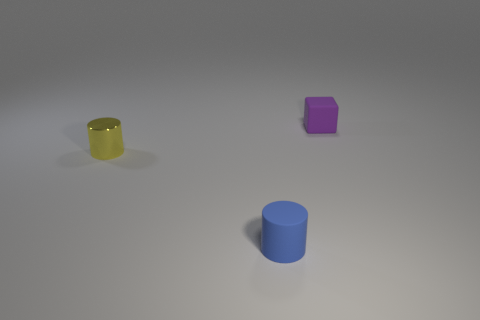What color is the other tiny thing that is the same shape as the small yellow object?
Provide a short and direct response. Blue. Are the blue cylinder and the yellow object made of the same material?
Your answer should be very brief. No. The metallic object that is the same size as the matte block is what color?
Your answer should be very brief. Yellow. Is there a tiny matte thing that has the same shape as the tiny yellow shiny thing?
Your response must be concise. Yes. There is a thing to the left of the matte object to the left of the rubber object behind the small yellow object; what is it made of?
Ensure brevity in your answer.  Metal. The metal thing is what color?
Your answer should be very brief. Yellow. How many rubber objects are large blue cylinders or purple objects?
Make the answer very short. 1. Is there any other thing that is the same material as the yellow thing?
Keep it short and to the point. No. What size is the matte object to the left of the rubber object to the right of the small rubber object to the left of the small purple object?
Give a very brief answer. Small. There is a thing that is right of the tiny metal thing and in front of the purple cube; how big is it?
Ensure brevity in your answer.  Small. 